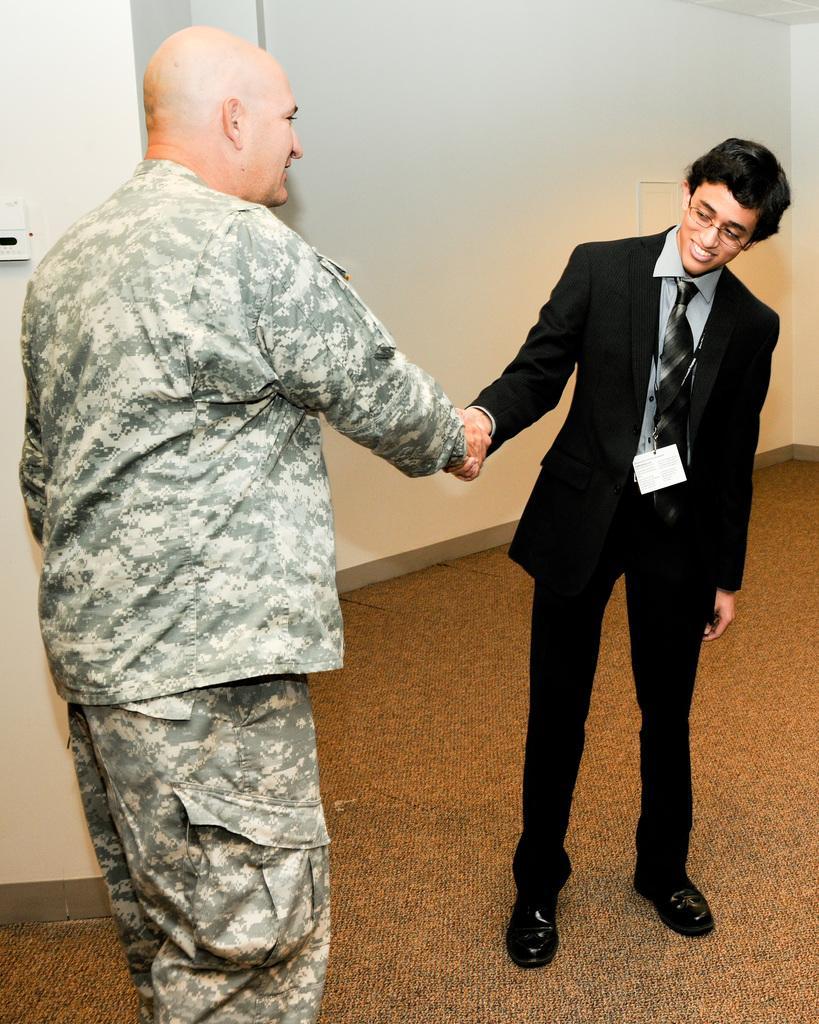How would you summarize this image in a sentence or two? In this image, at the left side there is a man standing and at the right side there is a person standing and wearing a black color coat, they are shaking hands, in the background there is a white color wall. 